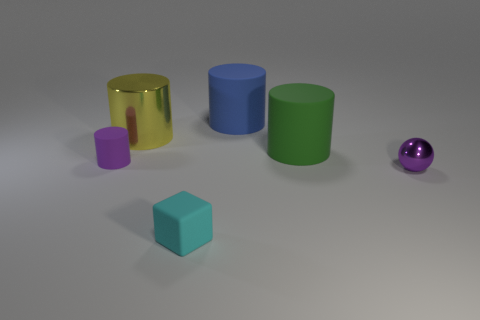What number of tiny matte cylinders are the same color as the small metallic thing?
Ensure brevity in your answer.  1. What size is the green cylinder that is the same material as the large blue cylinder?
Offer a very short reply. Large. Is the size of the purple thing to the right of the small purple matte thing the same as the cylinder on the left side of the large yellow object?
Ensure brevity in your answer.  Yes. There is a yellow object that is the same size as the green rubber object; what is its material?
Give a very brief answer. Metal. The tiny thing that is behind the tiny cyan cube and on the right side of the small cylinder is made of what material?
Offer a terse response. Metal. Is there a big brown matte cube?
Provide a succinct answer. No. Do the tiny cylinder and the tiny object on the right side of the large blue cylinder have the same color?
Provide a succinct answer. Yes. There is a tiny thing that is the same color as the sphere; what material is it?
Offer a terse response. Rubber. Is there anything else that has the same shape as the purple metallic thing?
Your answer should be compact. No. What is the shape of the tiny purple object that is in front of the rubber thing that is on the left side of the tiny object in front of the small sphere?
Ensure brevity in your answer.  Sphere. 